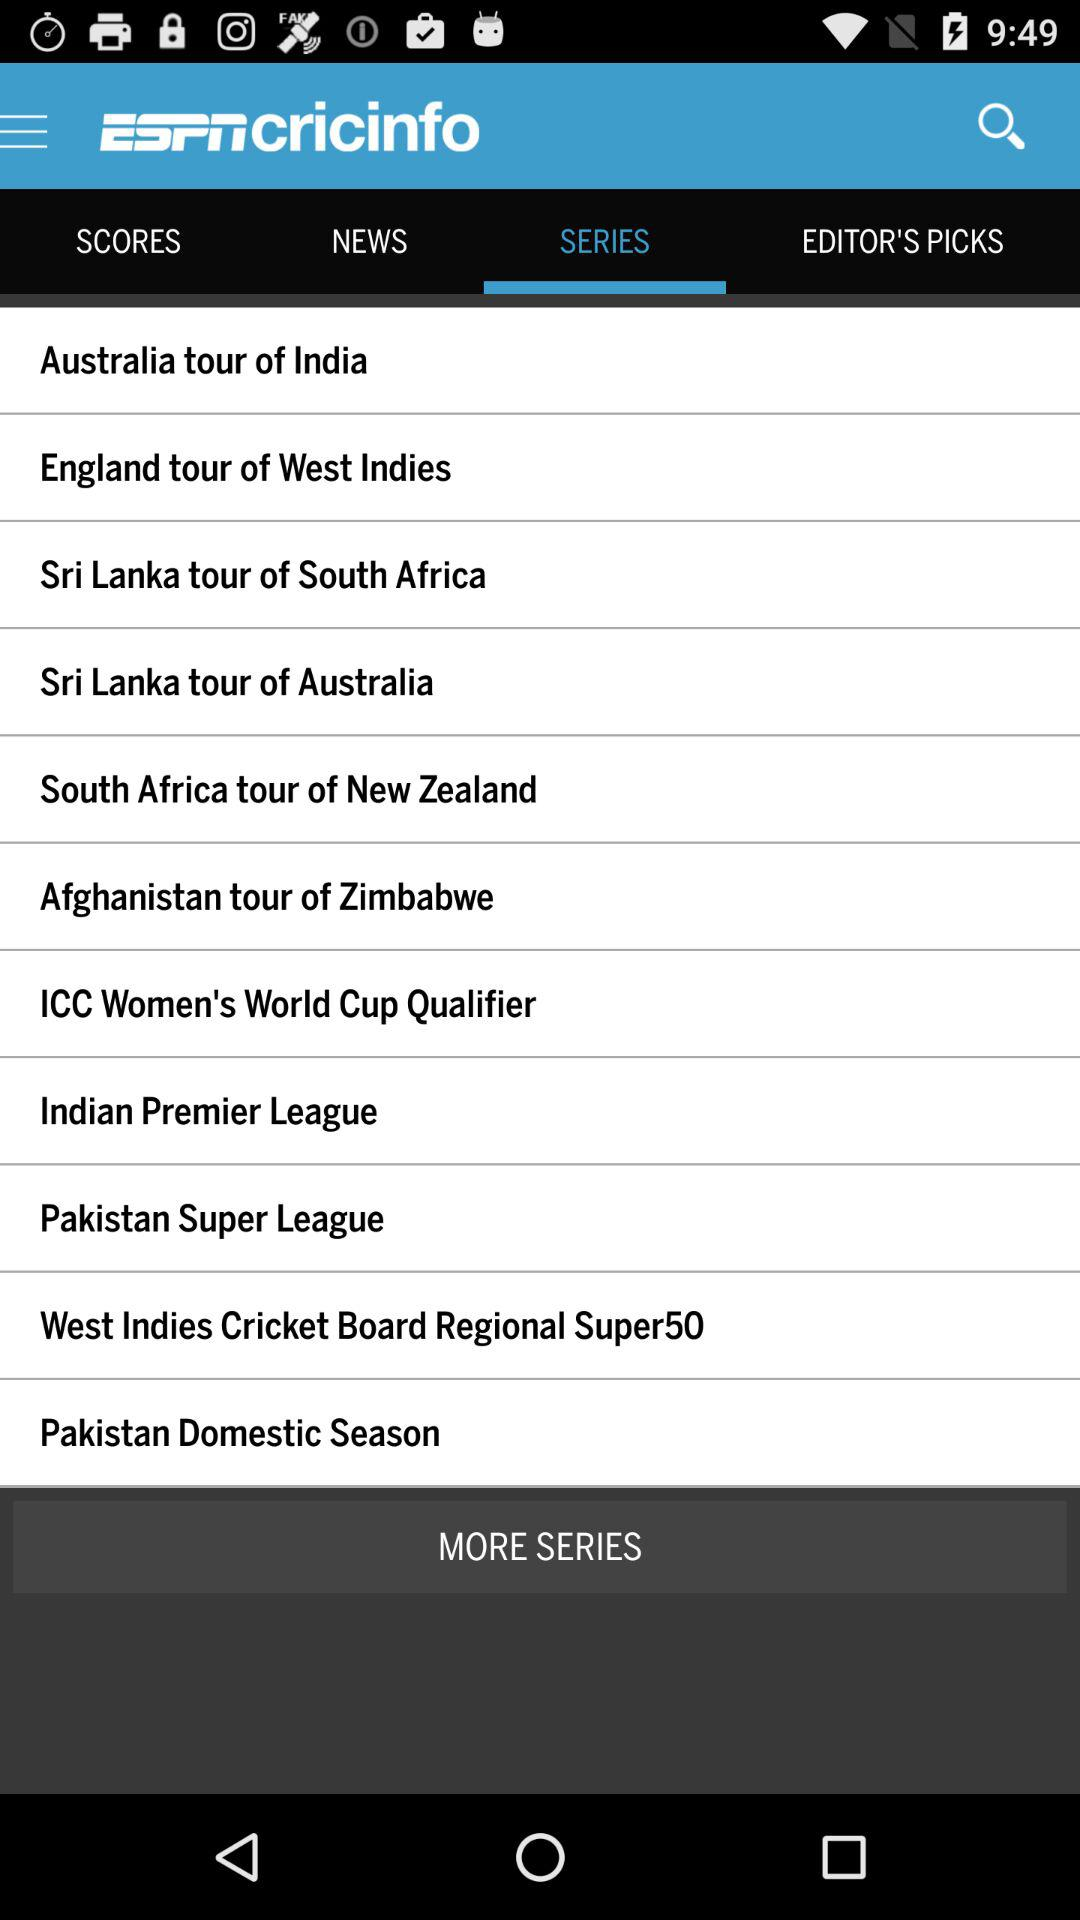What is the application name? The application name is "ESPNcricinfo". 